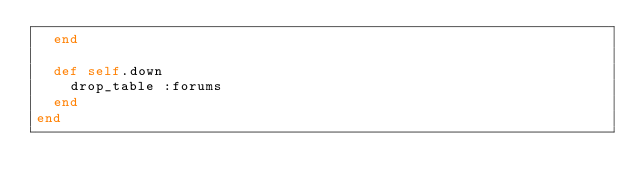Convert code to text. <code><loc_0><loc_0><loc_500><loc_500><_Ruby_>  end

  def self.down
    drop_table :forums
  end
end
</code> 